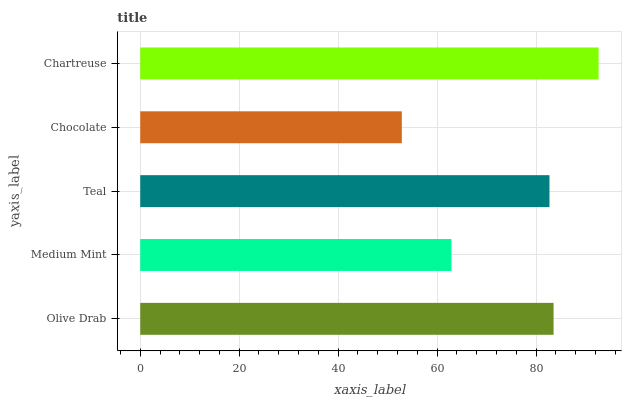Is Chocolate the minimum?
Answer yes or no. Yes. Is Chartreuse the maximum?
Answer yes or no. Yes. Is Medium Mint the minimum?
Answer yes or no. No. Is Medium Mint the maximum?
Answer yes or no. No. Is Olive Drab greater than Medium Mint?
Answer yes or no. Yes. Is Medium Mint less than Olive Drab?
Answer yes or no. Yes. Is Medium Mint greater than Olive Drab?
Answer yes or no. No. Is Olive Drab less than Medium Mint?
Answer yes or no. No. Is Teal the high median?
Answer yes or no. Yes. Is Teal the low median?
Answer yes or no. Yes. Is Medium Mint the high median?
Answer yes or no. No. Is Medium Mint the low median?
Answer yes or no. No. 